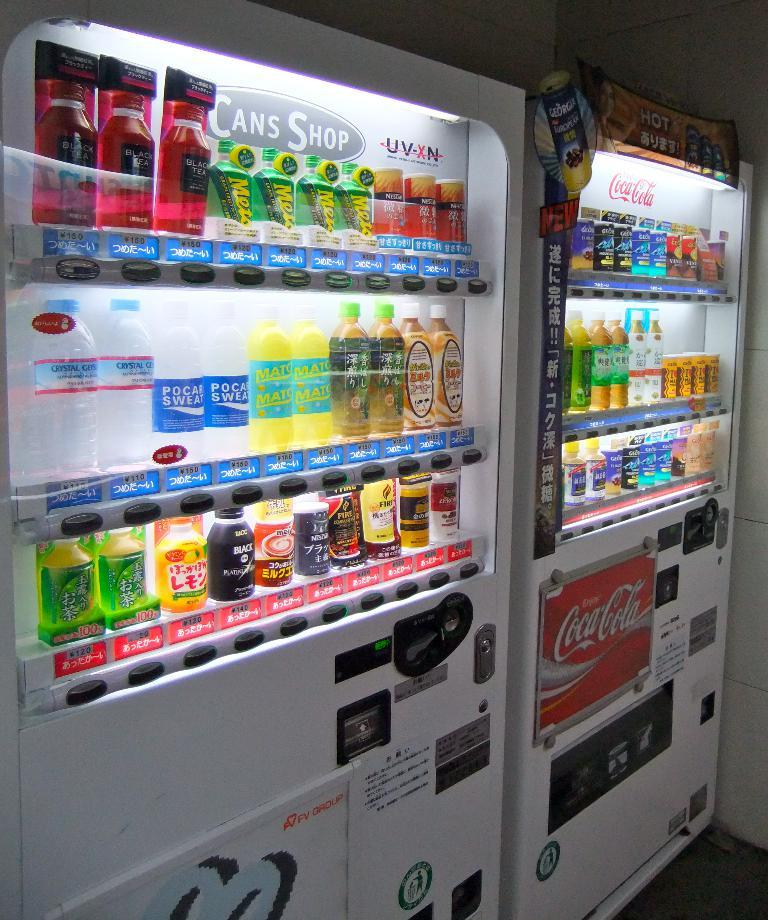<image>
Provide a brief description of the given image. Vending machines with different drink purchase options including CocaCola and UV-XN. 